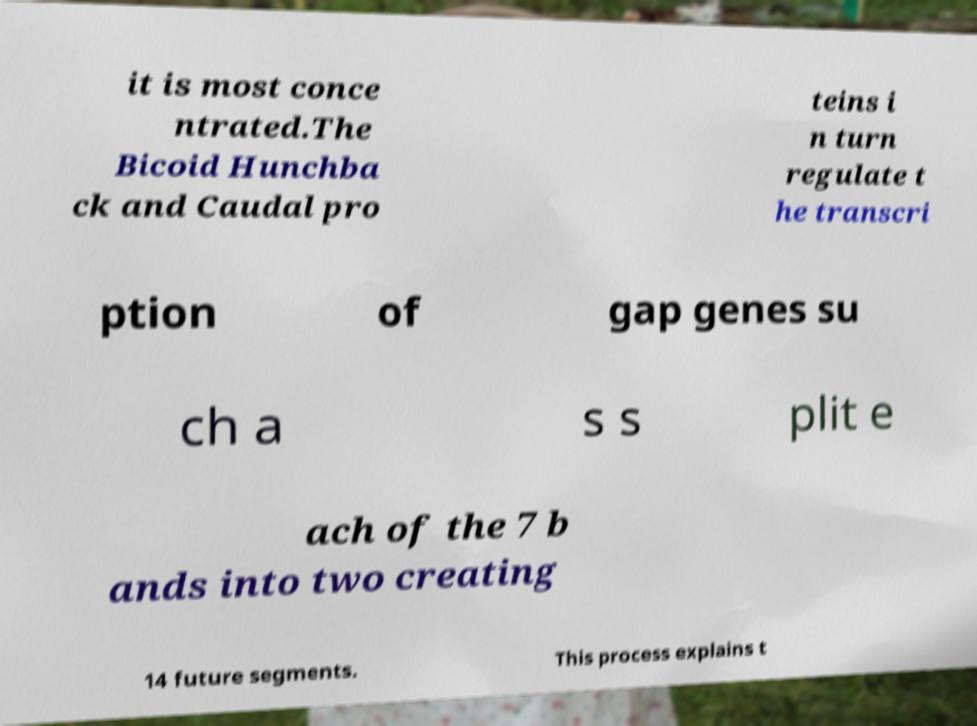Could you assist in decoding the text presented in this image and type it out clearly? it is most conce ntrated.The Bicoid Hunchba ck and Caudal pro teins i n turn regulate t he transcri ption of gap genes su ch a s s plit e ach of the 7 b ands into two creating 14 future segments. This process explains t 